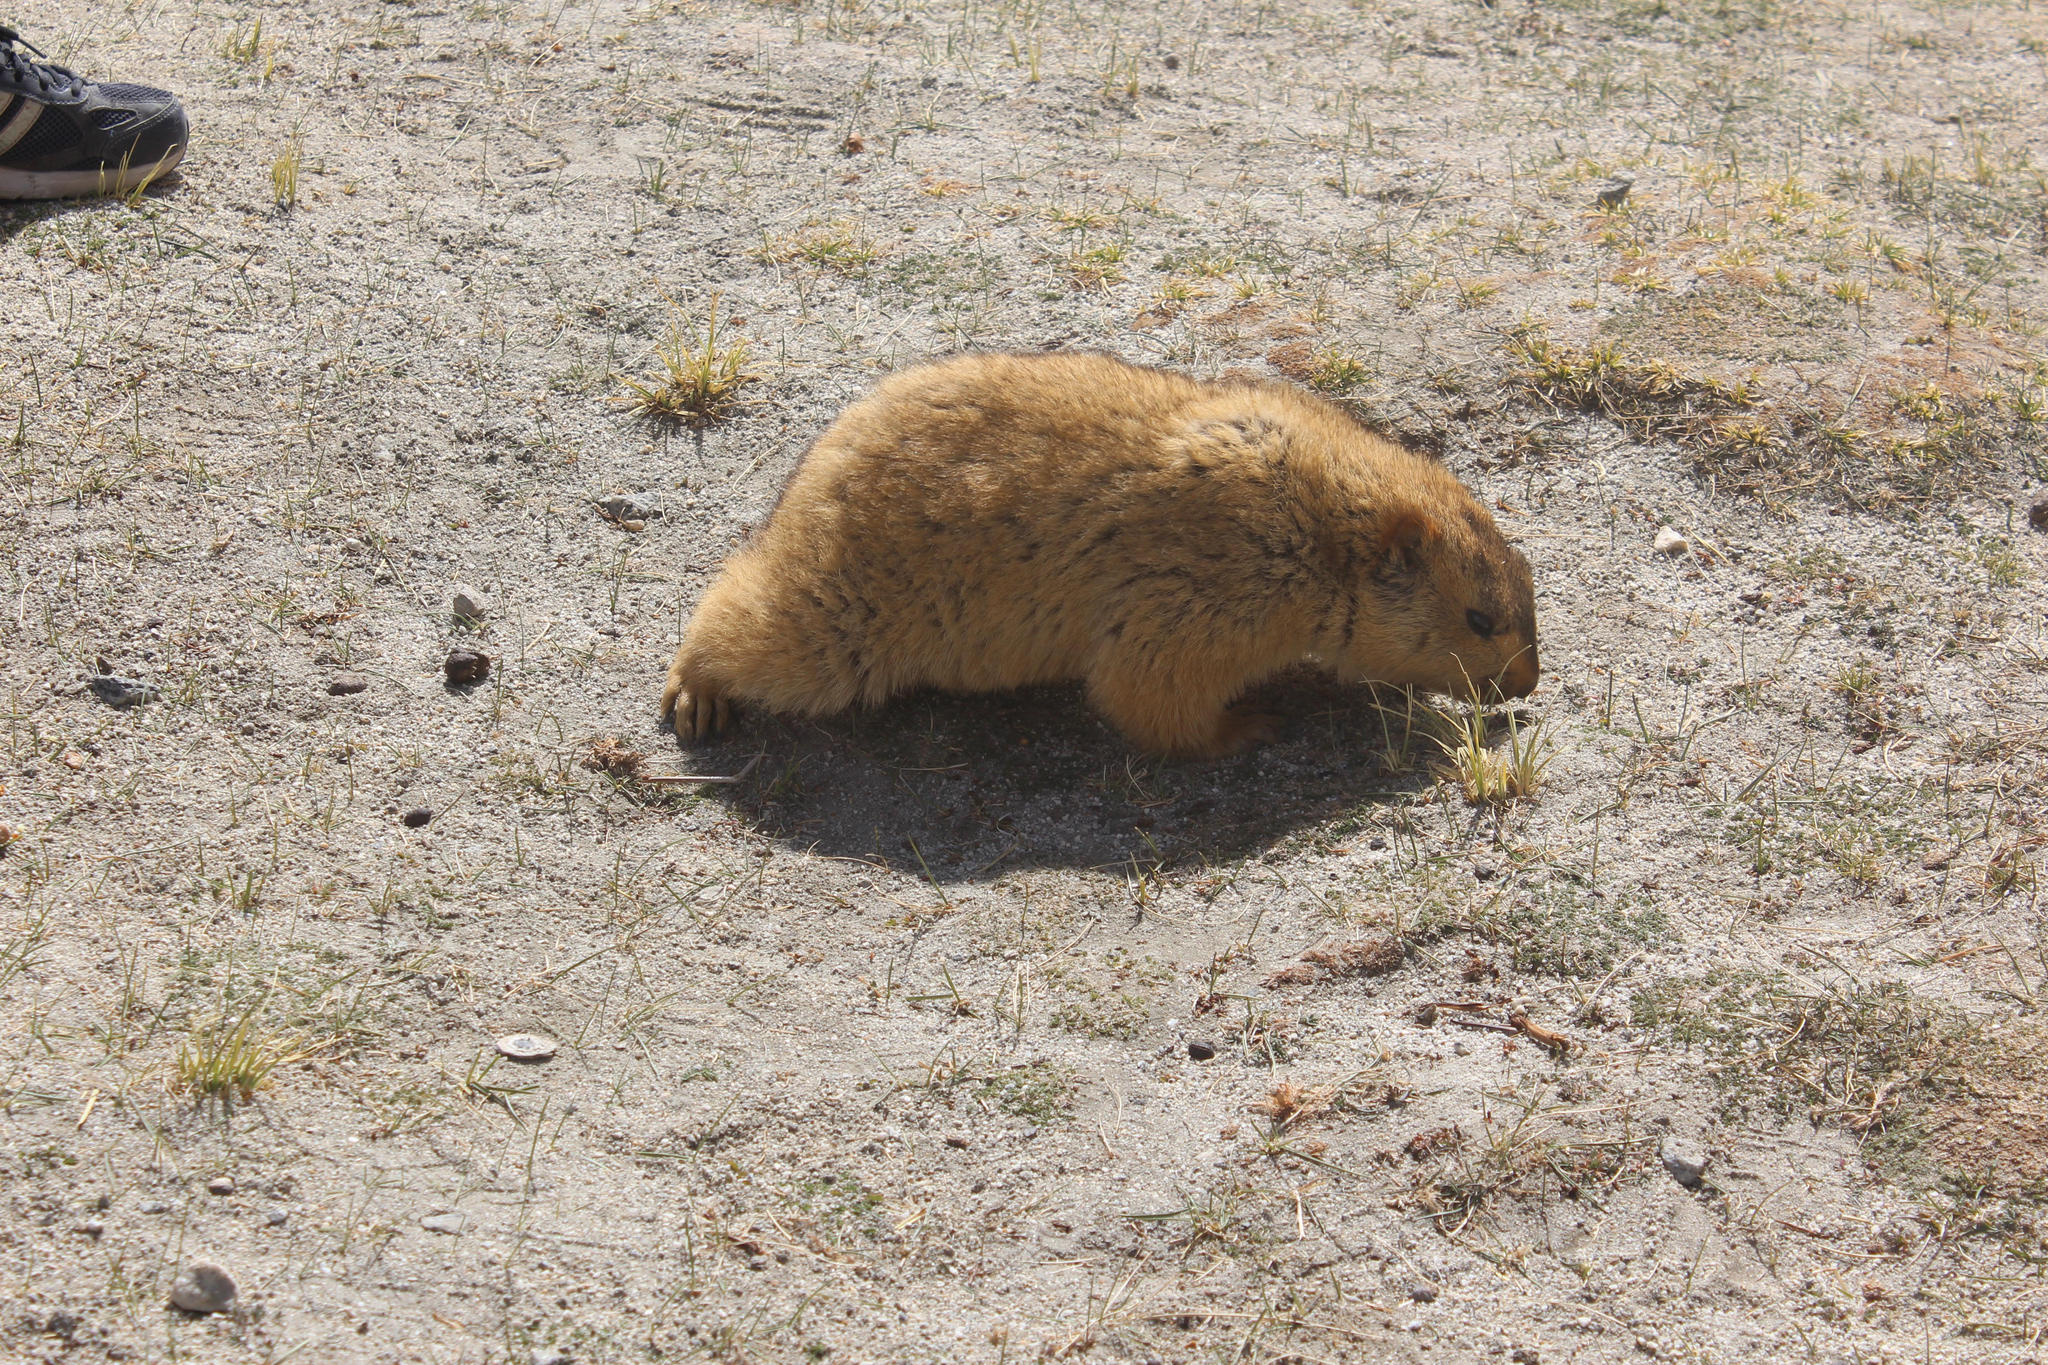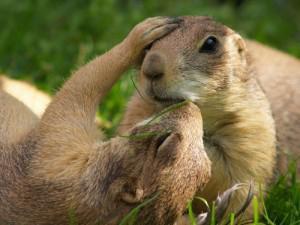The first image is the image on the left, the second image is the image on the right. Evaluate the accuracy of this statement regarding the images: "There is a total of three animals in the pair of images.". Is it true? Answer yes or no. Yes. The first image is the image on the left, the second image is the image on the right. For the images shown, is this caption "There are two marmots touching in the right image." true? Answer yes or no. Yes. 